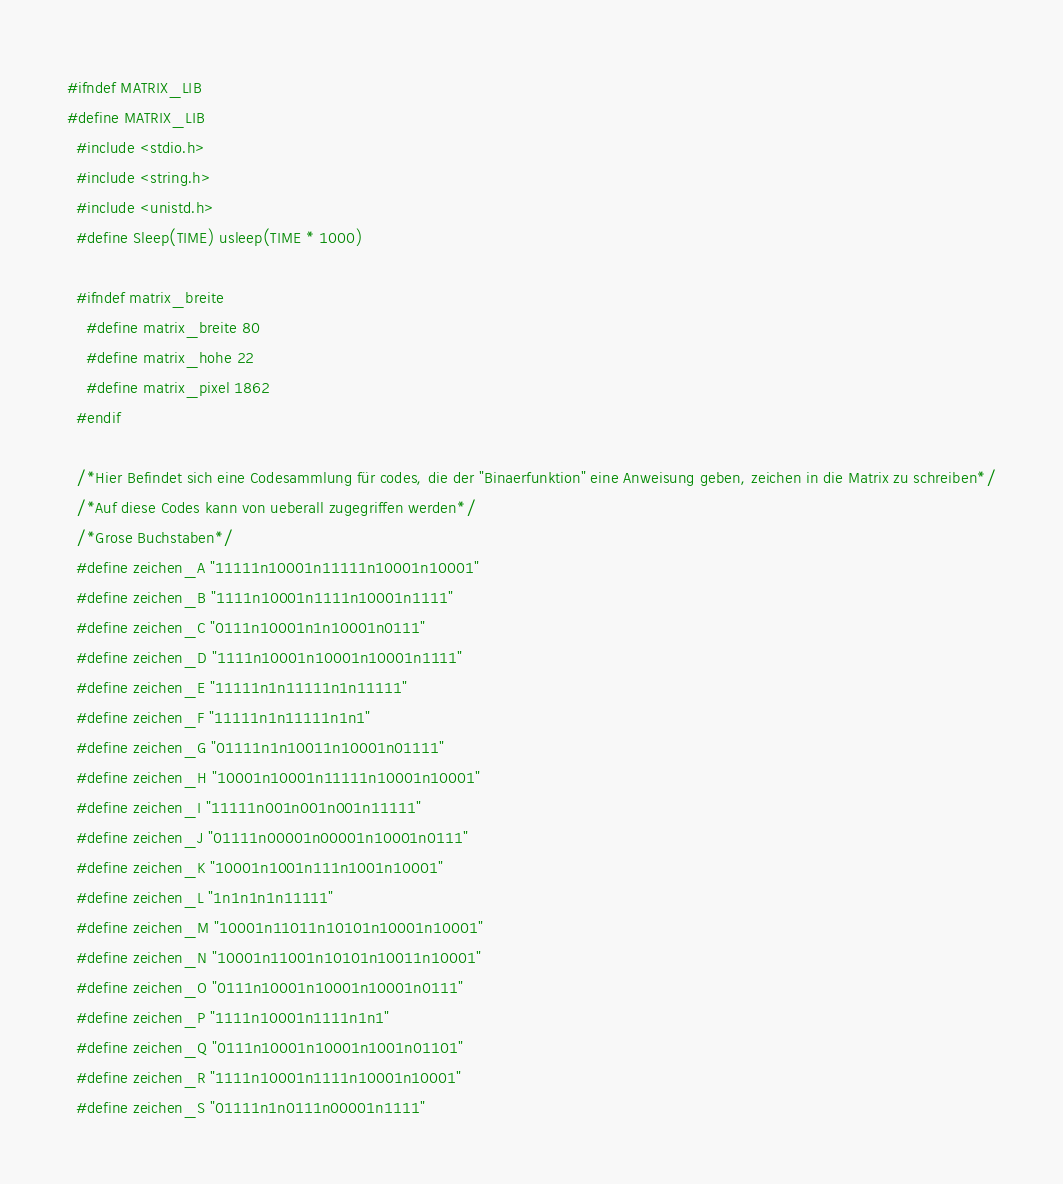Convert code to text. <code><loc_0><loc_0><loc_500><loc_500><_C_>#ifndef MATRIX_LIB
#define MATRIX_LIB
  #include <stdio.h>
  #include <string.h>
  #include <unistd.h>
  #define Sleep(TIME) usleep(TIME * 1000)

  #ifndef matrix_breite
    #define matrix_breite 80
    #define matrix_hohe 22
    #define matrix_pixel 1862
  #endif

  /*Hier Befindet sich eine Codesammlung für codes, die der "Binaerfunktion" eine Anweisung geben, zeichen in die Matrix zu schreiben*/
  /*Auf diese Codes kann von ueberall zugegriffen werden*/
  /*Grose Buchstaben*/
  #define zeichen_A "11111n10001n11111n10001n10001"
  #define zeichen_B "1111n10001n1111n10001n1111"
  #define zeichen_C "0111n10001n1n10001n0111"
  #define zeichen_D "1111n10001n10001n10001n1111"
  #define zeichen_E "11111n1n11111n1n11111"
  #define zeichen_F "11111n1n11111n1n1"
  #define zeichen_G "01111n1n10011n10001n01111"
  #define zeichen_H "10001n10001n11111n10001n10001"
  #define zeichen_I "11111n001n001n001n11111"
  #define zeichen_J "01111n00001n00001n10001n0111"
  #define zeichen_K "10001n1001n111n1001n10001"
  #define zeichen_L "1n1n1n1n11111"
  #define zeichen_M "10001n11011n10101n10001n10001"
  #define zeichen_N "10001n11001n10101n10011n10001"
  #define zeichen_O "0111n10001n10001n10001n0111"
  #define zeichen_P "1111n10001n1111n1n1"
  #define zeichen_Q "0111n10001n10001n1001n01101"
  #define zeichen_R "1111n10001n1111n10001n10001"
  #define zeichen_S "01111n1n0111n00001n1111"</code> 